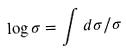<formula> <loc_0><loc_0><loc_500><loc_500>\log \sigma = \int d \sigma / \sigma</formula> 